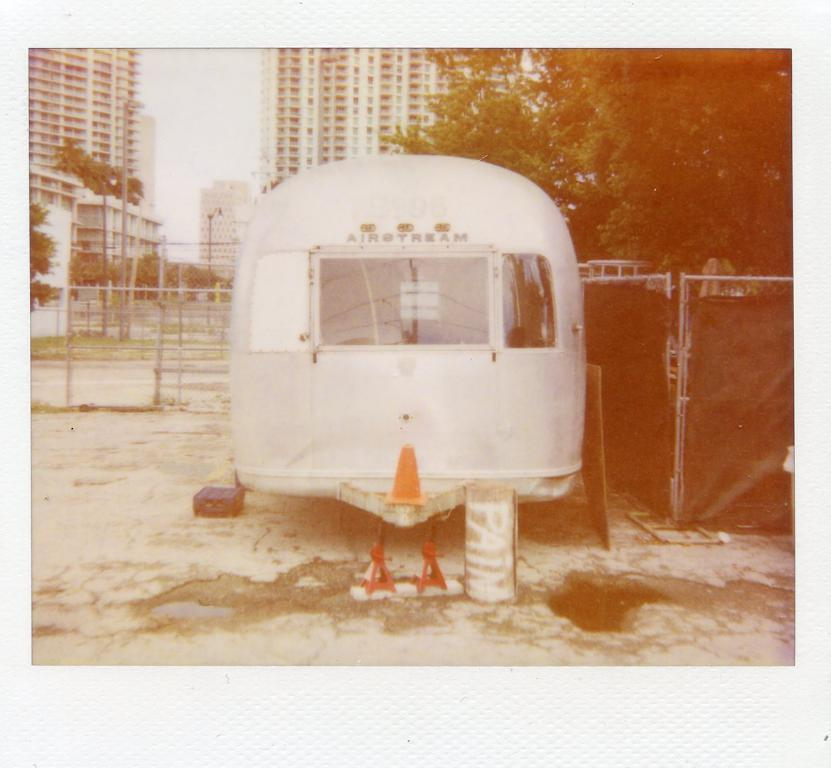What is the main subject of the image? There is a vehicle in the image. What other objects can be seen in the image? There is a road cone, a footpath, a fence, trees, a pole, and buildings in the image. Can you describe the buildings in the image? The buildings have windows, and the sky is visible in the image. What type of grass is growing on the bed in the image? There is no grass or bed present in the image. What is the outcome of the battle depicted in the image? There is no battle depicted in the image. 